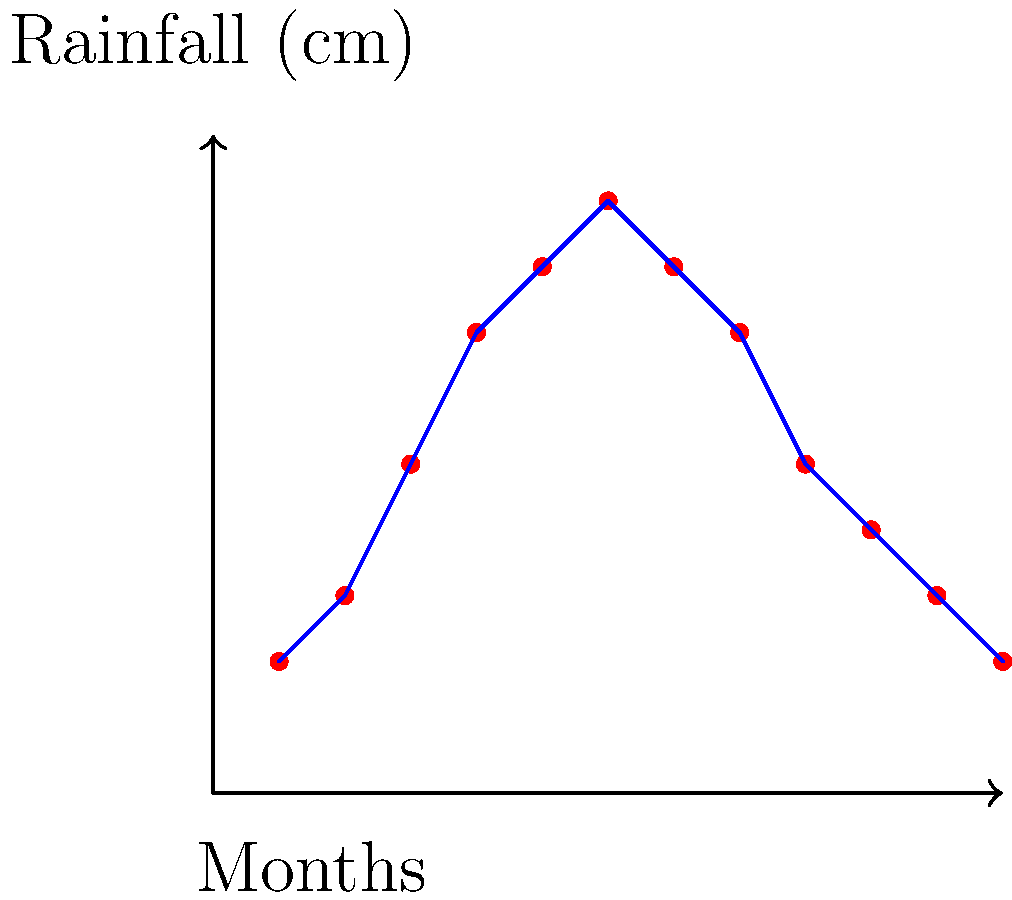As an indie musician with a knack for niche facts, you're designing a rainwater harvesting system for your recording studio. Given a roof area of 200 m² and the monthly rainfall data shown in the graph, what's the total volume of rainwater that could be collected in a year? Assume 80% collection efficiency. Let's break this down step-by-step, mixing in some music-related analogies:

1) First, we need to calculate the total rainfall for the year. Like compiling a year's worth of chart-topping hits, we'll sum up the rainfall for each month:

   $2 + 3 + 5 + 7 + 8 + 9 + 8 + 7 + 5 + 4 + 3 + 2 = 63$ cm

2) Convert this to meters: $63$ cm $= 0.63$ m

3) Now, like calculating the area of a stage, we'll use the formula for volume:
   
   Volume = Roof Area × Rainfall × Efficiency

4) Plug in the values:
   
   $V = 200$ m² $\times 0.63$ m $\times 0.80$

5) Calculate:
   
   $V = 100.8$ m³

6) Convert to liters (1 m³ = 1000 L):
   
   $100.8$ m³ $= 100,800$ L

So, just like how a platinum record represents a million sales, your roof could potentially collect 100,800 liters of rainwater in a year!
Answer: 100,800 L 